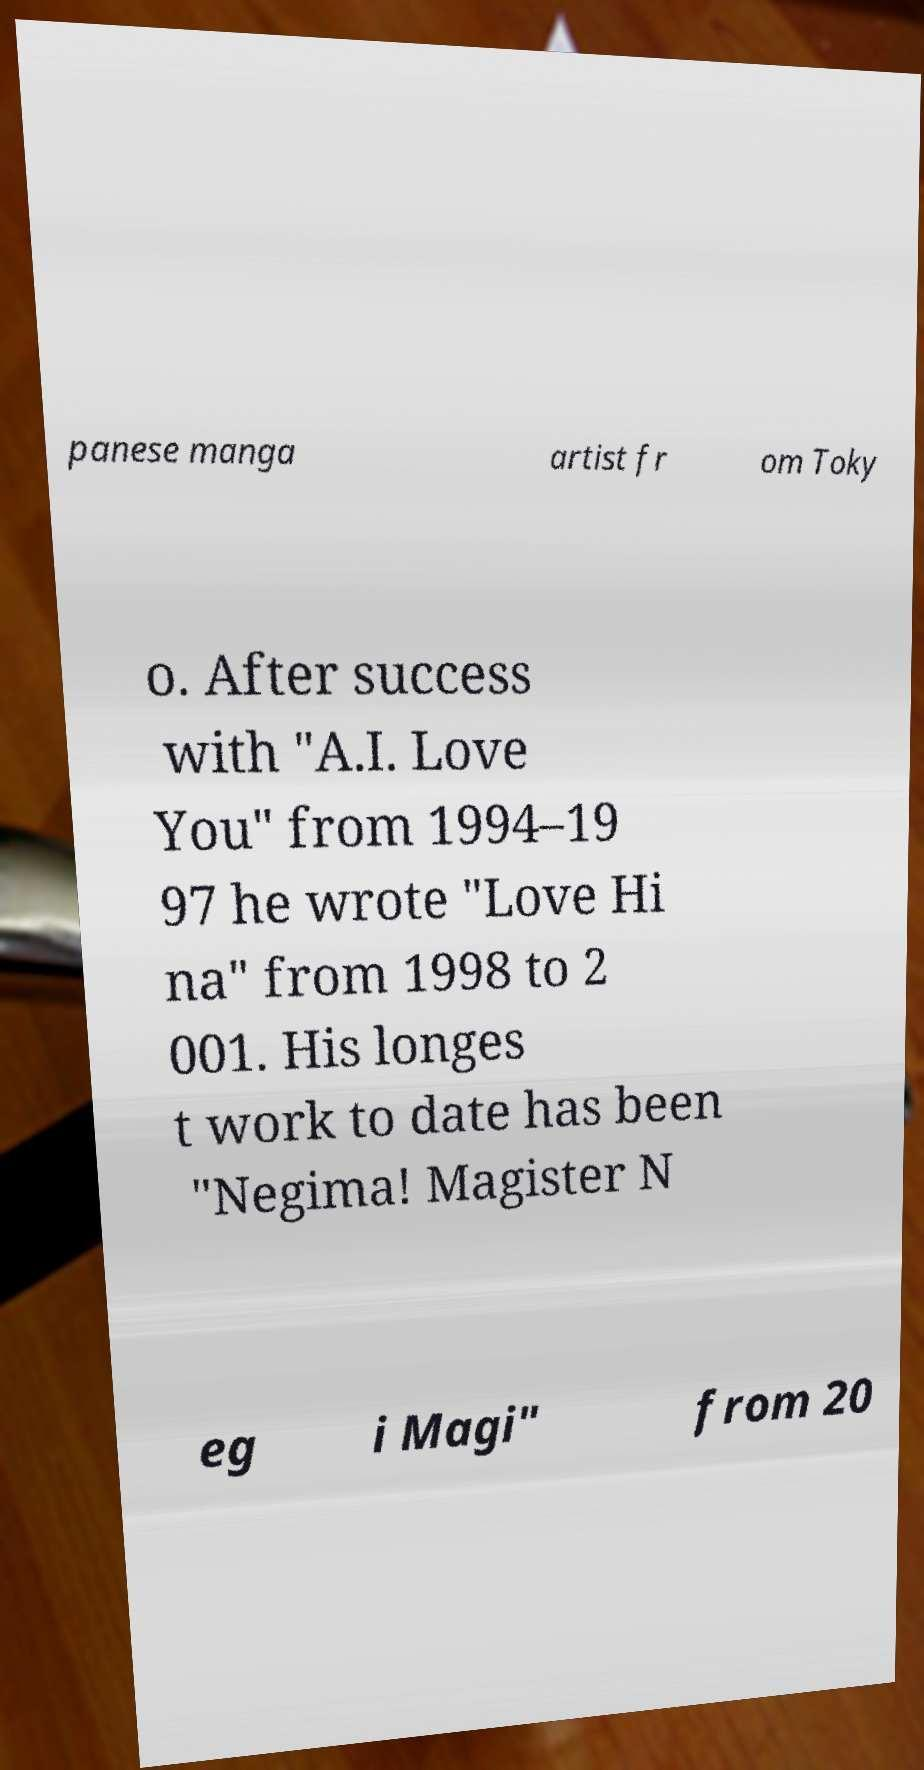Can you read and provide the text displayed in the image?This photo seems to have some interesting text. Can you extract and type it out for me? panese manga artist fr om Toky o. After success with "A.I. Love You" from 1994–19 97 he wrote "Love Hi na" from 1998 to 2 001. His longes t work to date has been "Negima! Magister N eg i Magi" from 20 